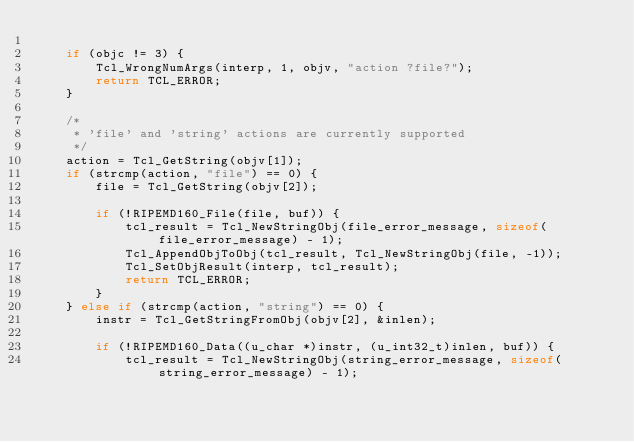Convert code to text. <code><loc_0><loc_0><loc_500><loc_500><_C_>
	if (objc != 3) {
		Tcl_WrongNumArgs(interp, 1, objv, "action ?file?");
		return TCL_ERROR;
	}

	/*
	 * 'file' and 'string' actions are currently supported
	 */
	action = Tcl_GetString(objv[1]);
	if (strcmp(action, "file") == 0) {
	    file = Tcl_GetString(objv[2]);

        if (!RIPEMD160_File(file, buf)) {
            tcl_result = Tcl_NewStringObj(file_error_message, sizeof(file_error_message) - 1);
            Tcl_AppendObjToObj(tcl_result, Tcl_NewStringObj(file, -1));
            Tcl_SetObjResult(interp, tcl_result);
            return TCL_ERROR;
        }
	} else if (strcmp(action, "string") == 0) {
	    instr = Tcl_GetStringFromObj(objv[2], &inlen);

	    if (!RIPEMD160_Data((u_char *)instr, (u_int32_t)inlen, buf)) {
            tcl_result = Tcl_NewStringObj(string_error_message, sizeof(string_error_message) - 1);</code> 